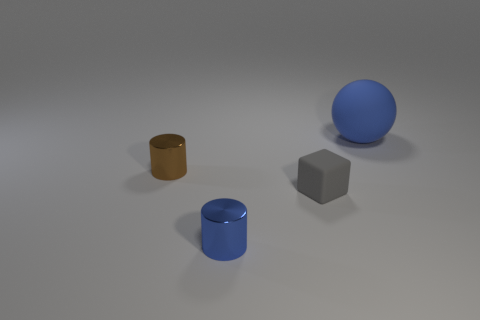Are there more tiny blocks that are behind the gray matte block than rubber things?
Offer a terse response. No. How many other objects are the same size as the blue shiny cylinder?
Give a very brief answer. 2. What number of small things are both in front of the gray rubber cube and behind the small blue object?
Your response must be concise. 0. Are the blue object in front of the big blue matte thing and the tiny gray object made of the same material?
Your answer should be compact. No. There is a tiny metal object that is behind the small metal thing that is in front of the small cube to the right of the blue shiny object; what is its shape?
Offer a very short reply. Cylinder. Are there an equal number of blue matte objects that are left of the small brown shiny cylinder and metallic objects that are to the right of the large blue object?
Ensure brevity in your answer.  Yes. What color is the cube that is the same size as the blue metal cylinder?
Keep it short and to the point. Gray. How many large objects are either red balls or gray rubber things?
Provide a succinct answer. 0. What is the object that is behind the gray cube and to the right of the small blue cylinder made of?
Your response must be concise. Rubber. Does the matte thing in front of the brown cylinder have the same shape as the metal object in front of the tiny gray thing?
Offer a terse response. No. 